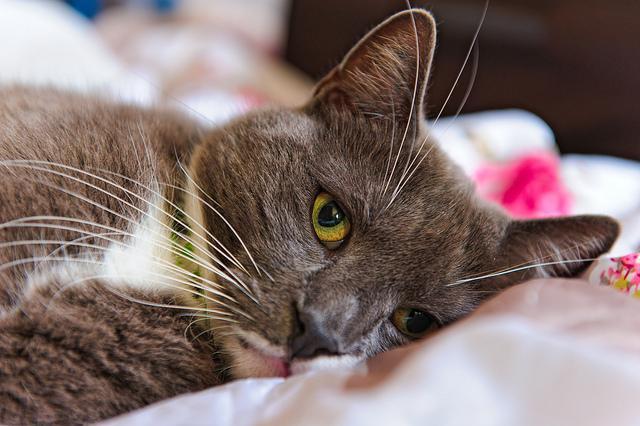How many people are shown in the picture?
Give a very brief answer. 0. 